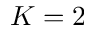Convert formula to latex. <formula><loc_0><loc_0><loc_500><loc_500>K = 2</formula> 